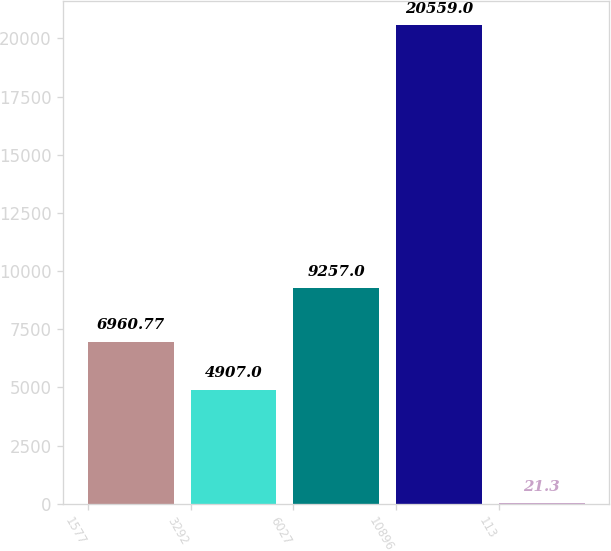Convert chart to OTSL. <chart><loc_0><loc_0><loc_500><loc_500><bar_chart><fcel>1577<fcel>3292<fcel>6027<fcel>10896<fcel>113<nl><fcel>6960.77<fcel>4907<fcel>9257<fcel>20559<fcel>21.3<nl></chart> 